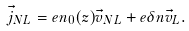<formula> <loc_0><loc_0><loc_500><loc_500>\vec { j } _ { N L } = e n _ { 0 } ( z ) \vec { v } _ { N L } + e \delta n \vec { v } _ { L } .</formula> 